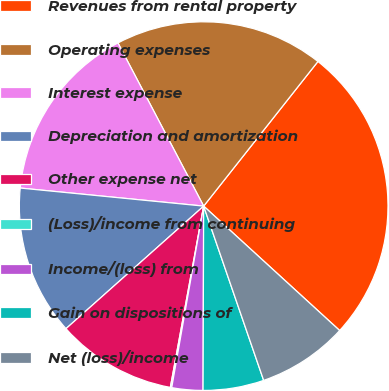Convert chart to OTSL. <chart><loc_0><loc_0><loc_500><loc_500><pie_chart><fcel>Revenues from rental property<fcel>Operating expenses<fcel>Interest expense<fcel>Depreciation and amortization<fcel>Other expense net<fcel>(Loss)/income from continuing<fcel>Income/(loss) from<fcel>Gain on dispositions of<fcel>Net (loss)/income<nl><fcel>26.15%<fcel>18.34%<fcel>15.74%<fcel>13.14%<fcel>10.53%<fcel>0.12%<fcel>2.72%<fcel>5.33%<fcel>7.93%<nl></chart> 